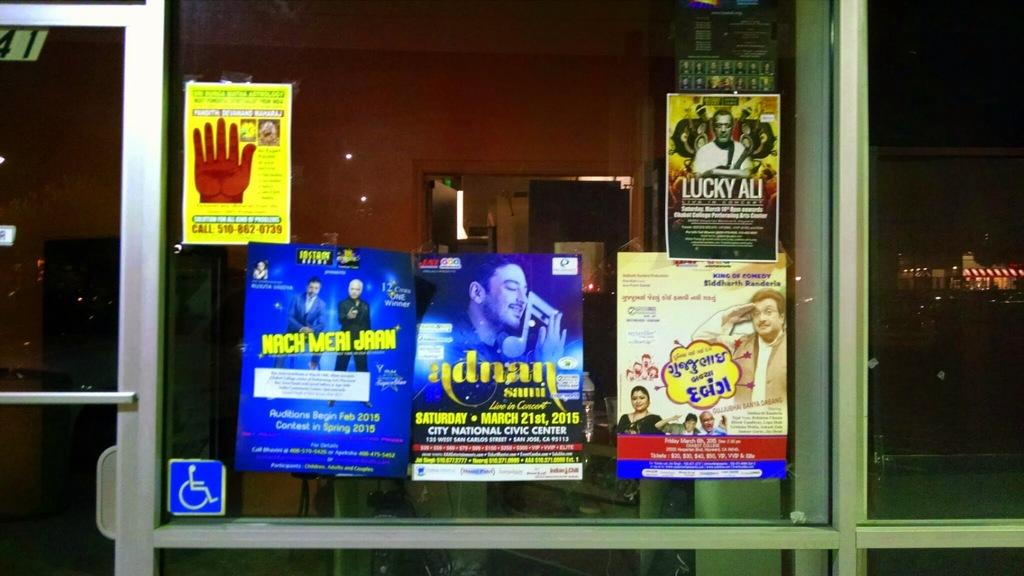<image>
Render a clear and concise summary of the photo. A number of ads are stuck to a window, one of which advertises Lucky Ali. 